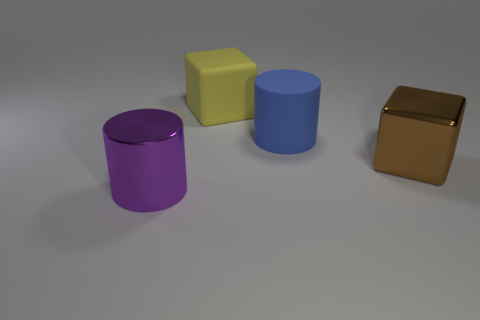Can you describe the colors of the objects shown in the image? Certainly! The image includes four objects, each with its own distinct color. We have a purple cylinder, a yellow cube, a blue cylinder, and a brown cube with a texture that gives it a metallic appearance. Do the objects have any shadows? Yes, each object casts a shadow on the ground, which suggests a light source within the scene. The shadows are slightly soft-edged, indicating diffuse lighting. 